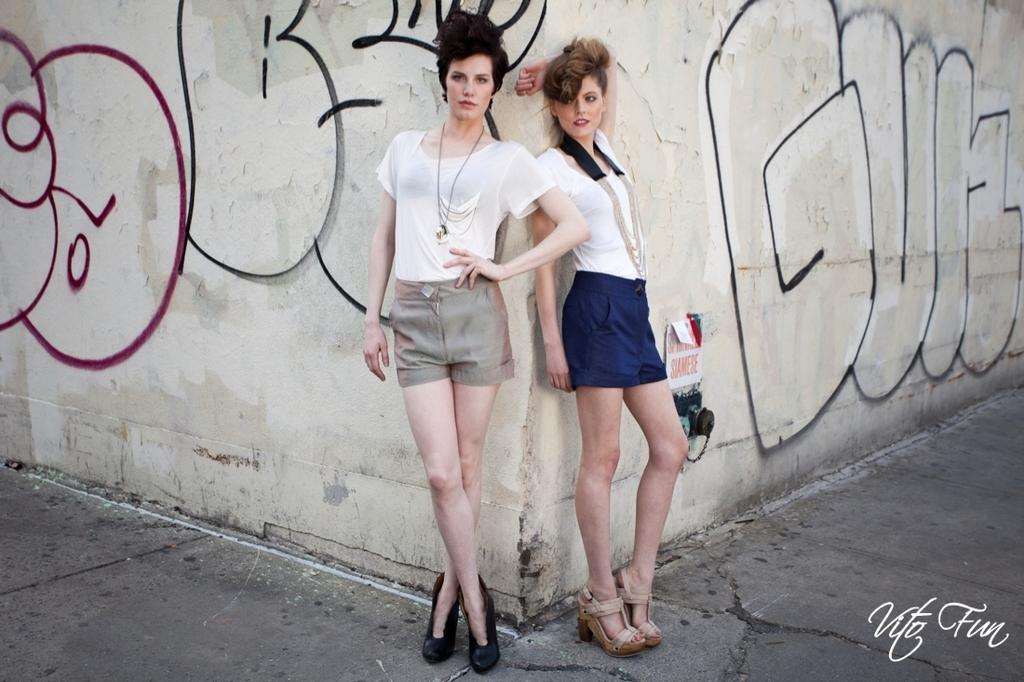How many people are in the image? There are two persons standing in the image. What is the surface they are standing on? The persons are standing on the floor. What can be seen in the background of the image? There is a wall in the background of the image. Are there any objects on the wall? Yes, there are objects on the wall. What type of bird is perched on the instrument in the image? There is no bird or instrument present in the image. 